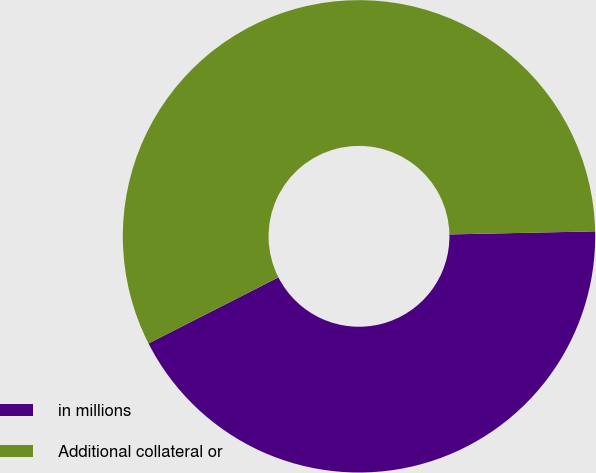Convert chart. <chart><loc_0><loc_0><loc_500><loc_500><pie_chart><fcel>in millions<fcel>Additional collateral or<nl><fcel>42.84%<fcel>57.16%<nl></chart> 